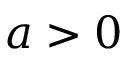<formula> <loc_0><loc_0><loc_500><loc_500>a > 0</formula> 